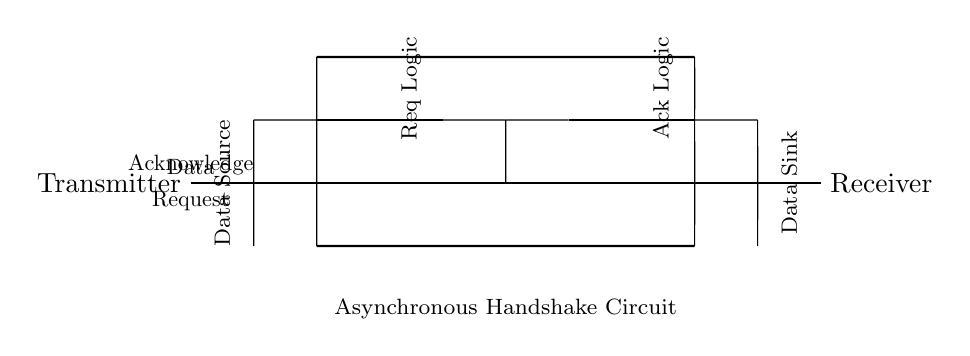What is the function of the buffer in the circuit? The buffer is used to isolate and amplify the signal, ensuring that data can be transmitted without interference or degradation.
Answer: To isolate and amplify What do the thick lines in the circuit represent? The thick lines represent the main communication lines: Data, Request, and Acknowledge, which facilitate the asynchronous handshake between the transmitter and receiver.
Answer: Communication lines What component represents the data source? The data source is represented by the node labeled 'Transmitter' on the left side of the circuit diagram.
Answer: Transmitter Which two logic elements are present in the circuit? The circuit contains Request Logic and Acknowledge Logic, which manage the handshaking process for data transfer.
Answer: Request Logic, Acknowledge Logic How many handshake signals are shown in the circuit? There are two handshake signals shown: Request and Acknowledge, which are essential for managing the data flow.
Answer: Two In which direction does the data flow in this circuit? The data flows from the Transmitter on the left to the Receiver on the right, as indicated by the arrangement of the components.
Answer: Left to right What type of communication does this circuit facilitate? This circuit facilitates asynchronous communication, allowing devices to send and receive data without needing to be synchronized at all times.
Answer: Asynchronous communication 